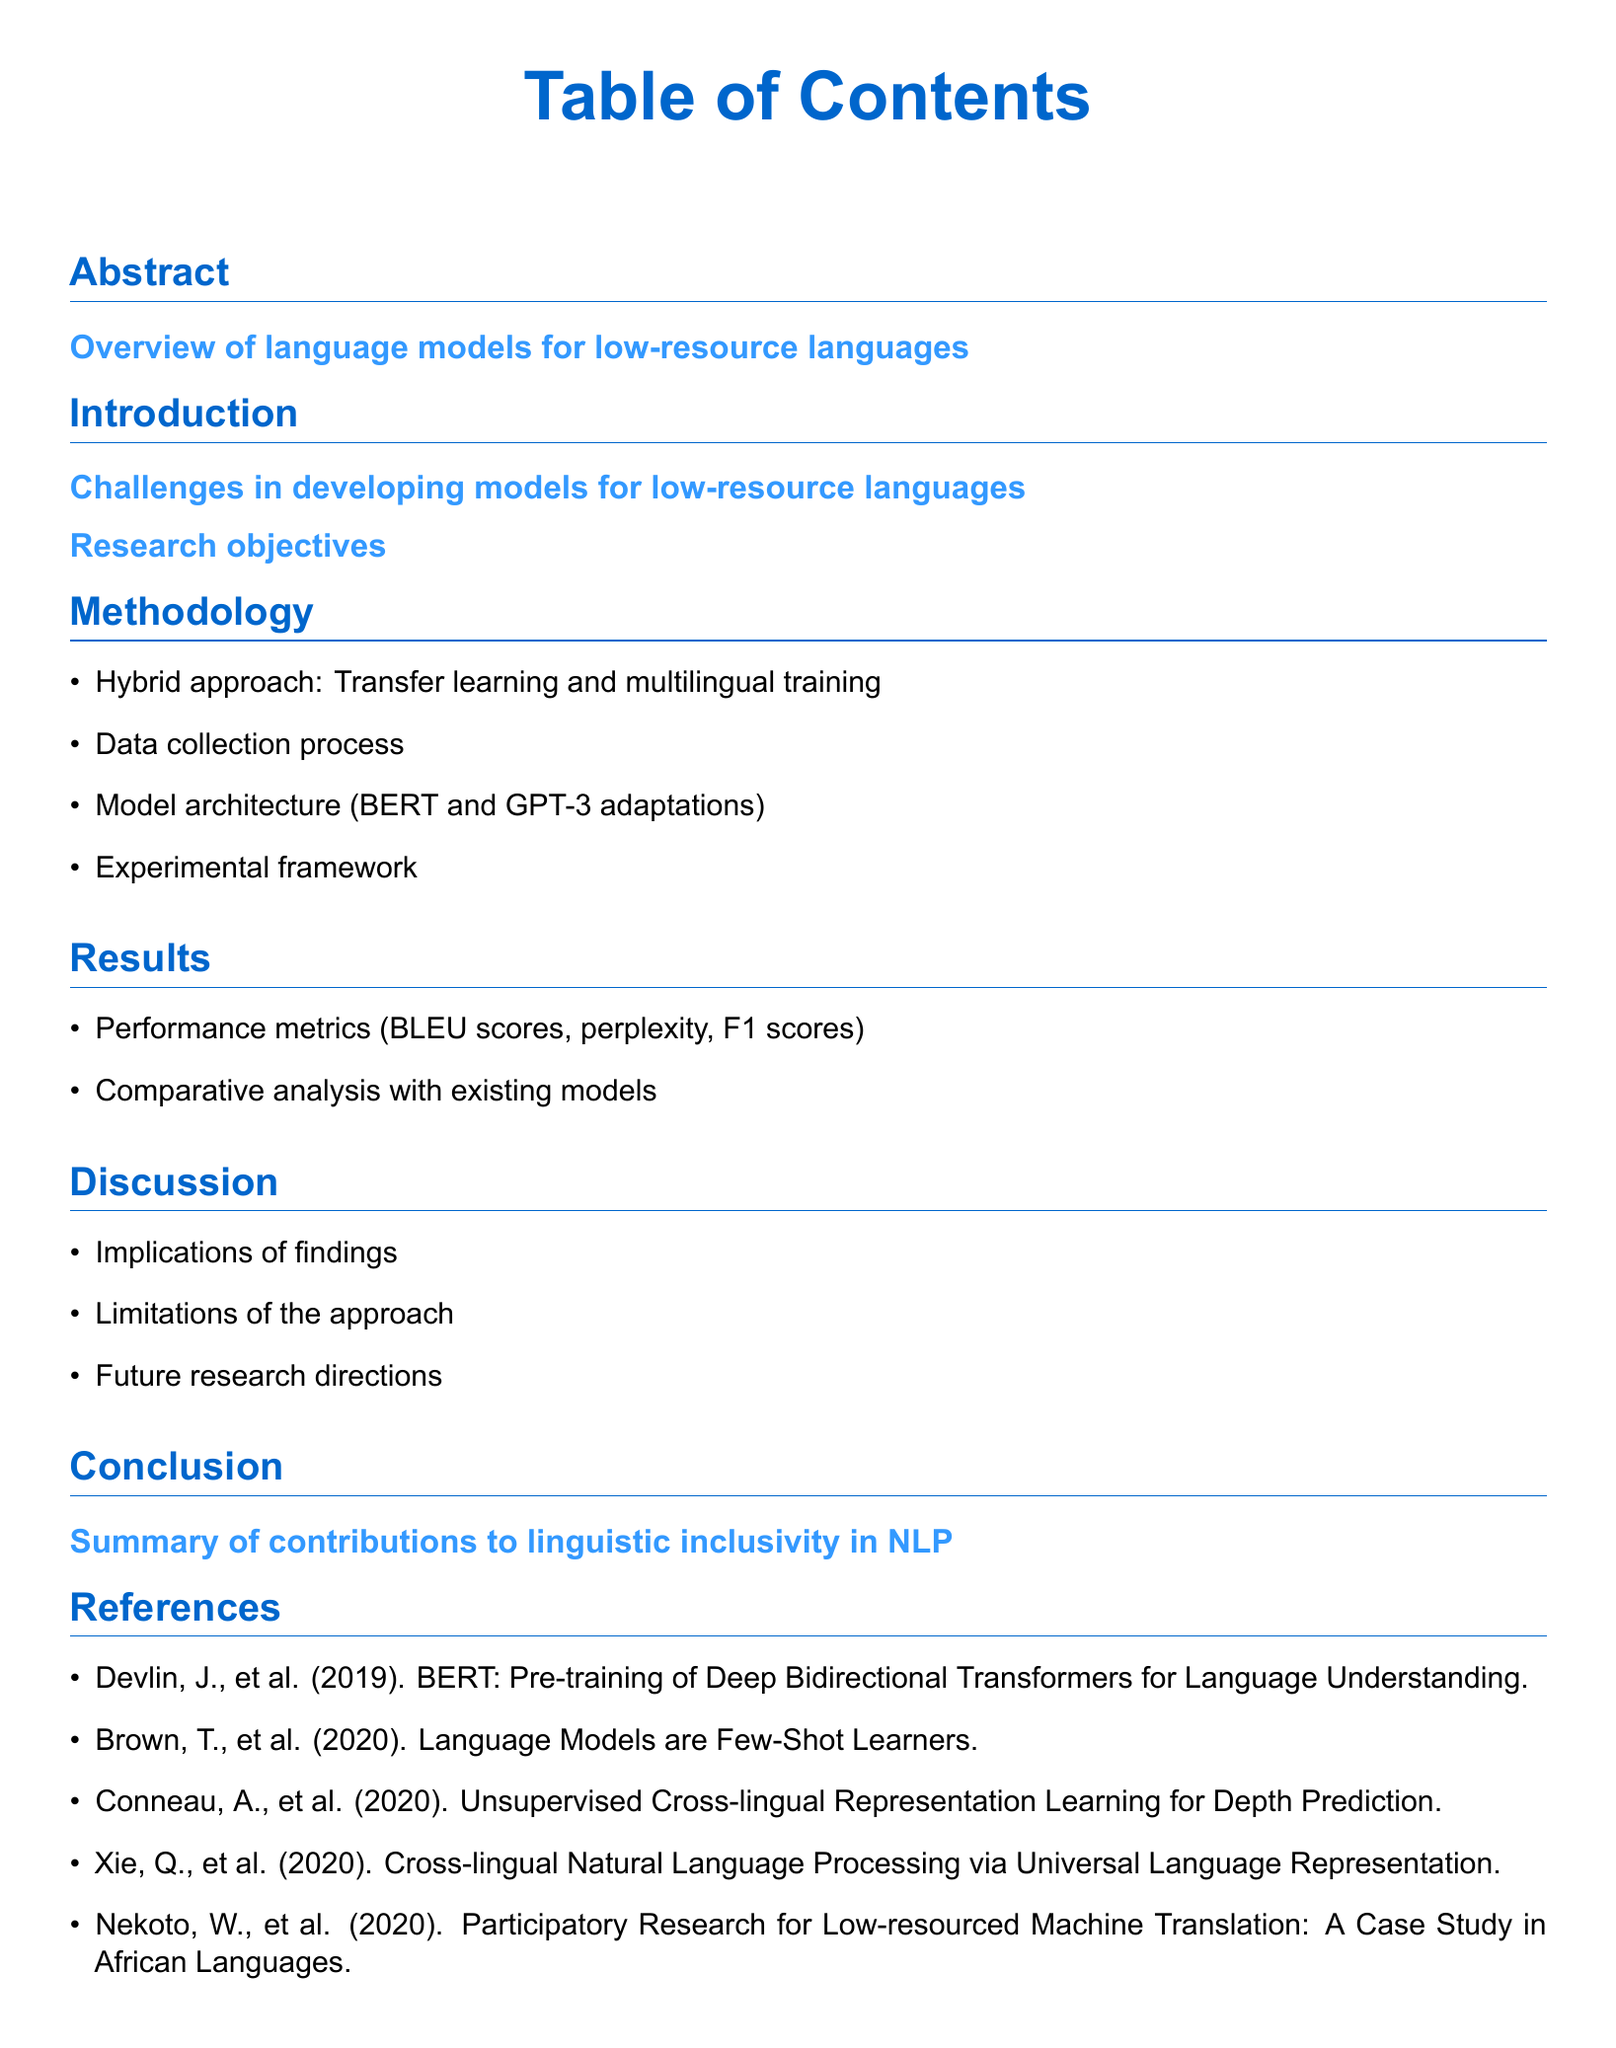What is the main topic of the abstract? The abstract provides an overview of language models specifically focusing on low-resource languages.
Answer: Overview of language models for low-resource languages What is the first challenge mentioned in the introduction? The first challenge is specifically referred to in the introduction section regarding developing models for low-resource languages.
Answer: Challenges in developing models for low-resource languages What type of methodology is used in this research? The methodology section outlines a hybrid approach combining two techniques for model development.
Answer: Hybrid approach: Transfer learning and multilingual training What metrics are mentioned in the results section? The results section highlights several performance metrics used to evaluate the models.
Answer: BLEU scores, perplexity, F1 scores What does the discussion address regarding the findings? The discussion section includes implications from the findings as well as the limitations of the approach.
Answer: Implications of findings How does the conclusion summarize the research contributions? The conclusion provides a summary specific to the contributions made by the research in a certain field.
Answer: Summary of contributions to linguistic inclusivity in NLP Who is the first author mentioned in the references? The references section lists several publications including the author's name, which is often listed first.
Answer: Devlin, J How many performance metrics are listed in the results? The results section enumerates the metrics that were evaluated throughout the study.
Answer: Three metrics Which section discusses future research directions? The future research directions are outlined in the discussion section.
Answer: Future research directions 